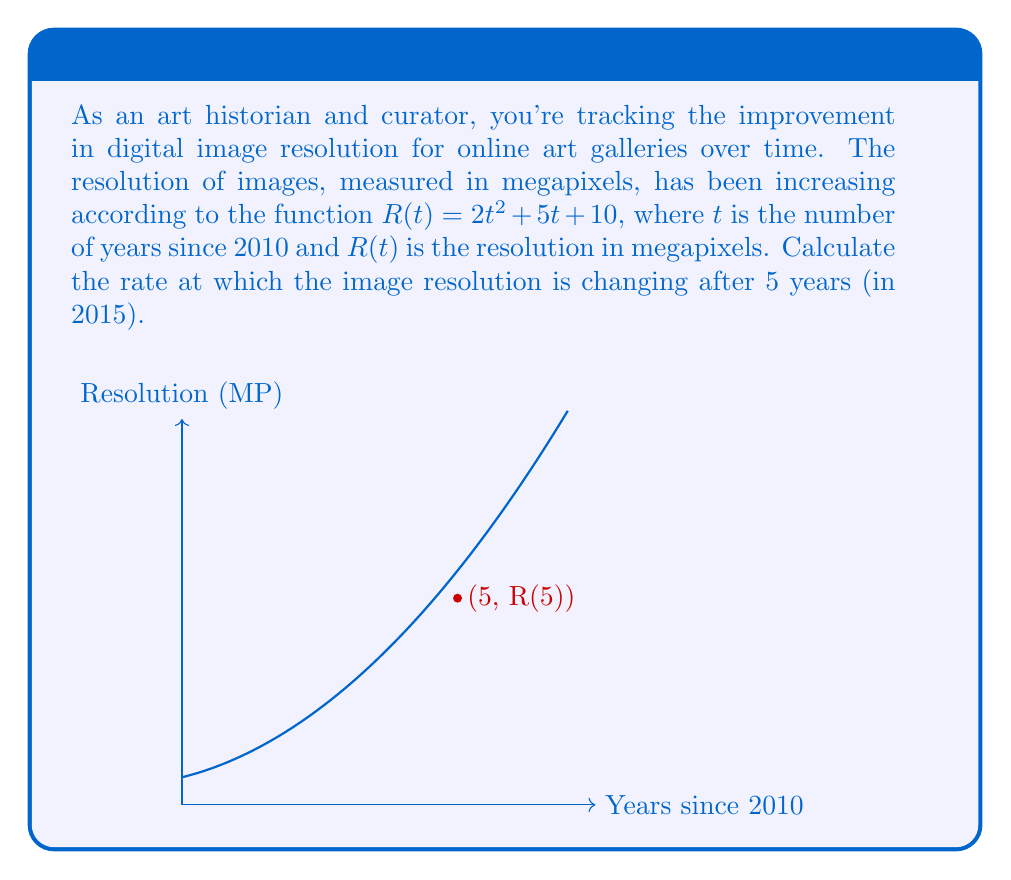Provide a solution to this math problem. To find the rate of change of the image resolution after 5 years, we need to calculate the derivative of $R(t)$ and evaluate it at $t=5$. Let's proceed step by step:

1) The given function is $R(t) = 2t^2 + 5t + 10$

2) To find the rate of change, we need to differentiate $R(t)$ with respect to $t$:
   $$R'(t) = \frac{d}{dt}(2t^2 + 5t + 10)$$

3) Using the power rule and constant rule of differentiation:
   $$R'(t) = 4t + 5$$

4) This derivative $R'(t)$ represents the instantaneous rate of change of resolution with respect to time.

5) To find the rate of change after 5 years, we evaluate $R'(t)$ at $t=5$:
   $$R'(5) = 4(5) + 5 = 20 + 5 = 25$$

Therefore, after 5 years (in 2015), the resolution is increasing at a rate of 25 megapixels per year.
Answer: 25 megapixels/year 